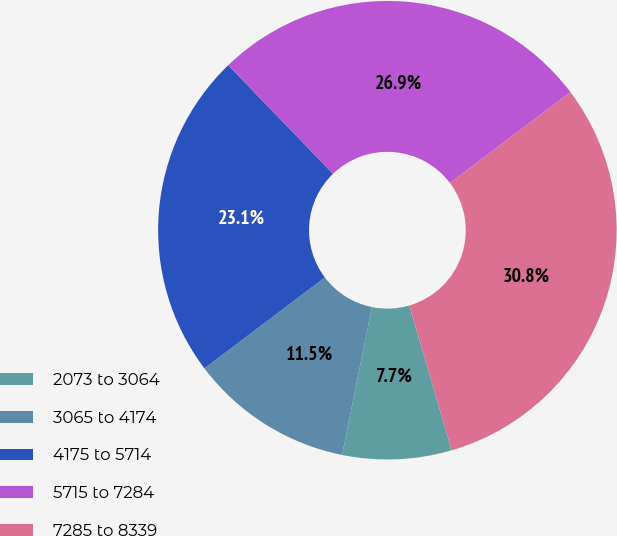Convert chart. <chart><loc_0><loc_0><loc_500><loc_500><pie_chart><fcel>2073 to 3064<fcel>3065 to 4174<fcel>4175 to 5714<fcel>5715 to 7284<fcel>7285 to 8339<nl><fcel>7.69%<fcel>11.54%<fcel>23.08%<fcel>26.92%<fcel>30.77%<nl></chart> 